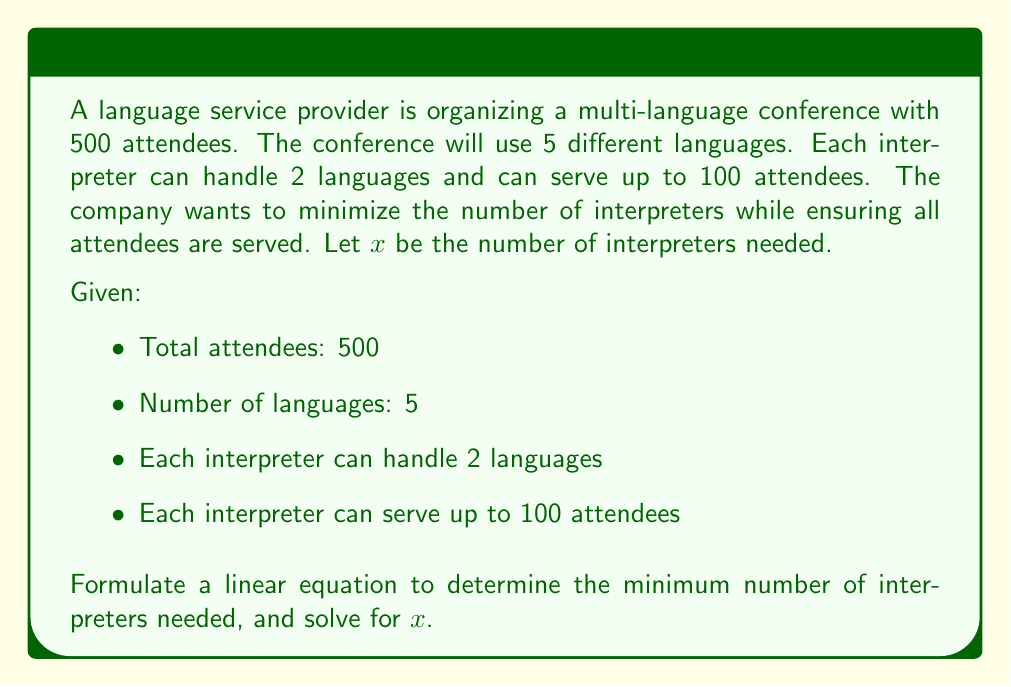Can you solve this math problem? To solve this problem, we need to consider both the language coverage and the attendee capacity constraints:

1. Language coverage constraint:
   Each interpreter covers 2 languages, so we need enough interpreters to cover all 5 languages.
   $$2x \geq 5$$

2. Attendee capacity constraint:
   Each interpreter can serve up to 100 attendees, so we need enough interpreters to serve all 500 attendees.
   $$100x \geq 500$$

3. Simplify the attendee capacity constraint:
   $$x \geq 5$$

4. Compare the two constraints:
   From (1): $x \geq 2.5$
   From (3): $x \geq 5$

   The stricter constraint is $x \geq 5$

5. Since we're looking for the minimum number of interpreters, and $x$ must be a whole number, we can conclude:

   $$x = 5$$

This solution satisfies both constraints:
- 5 interpreters can cover all 5 languages (each handling 2 languages with overlap)
- 5 interpreters can serve up to 500 attendees (5 * 100 = 500)
Answer: The minimum number of interpreters needed is 5. 